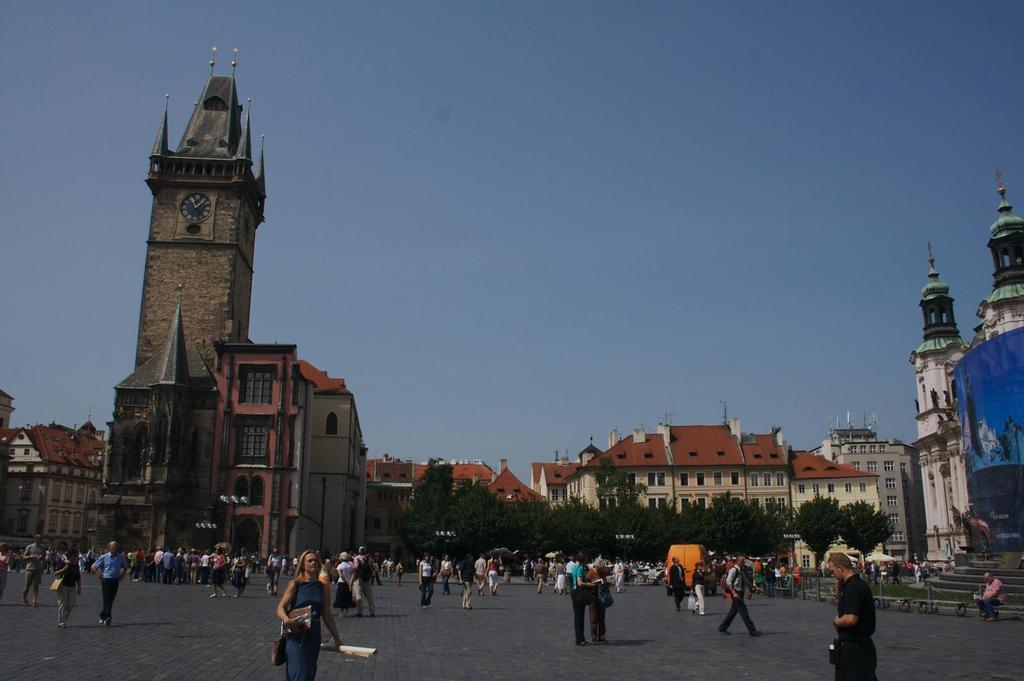What are the people in the image doing? The people in the image are walking. What type of natural elements can be seen in the image? There are trees in the image. What type of man-made structures are visible in the image? There are buildings in the image. What is the color of the sky in the image? The sky is visible at the top of the image, and it is blue. Where is the playground located in the image? There is no playground present in the image. What is the temper of the trees in the image? The provided facts do not mention the temper of the trees, and there is no indication of their temper in the image. 